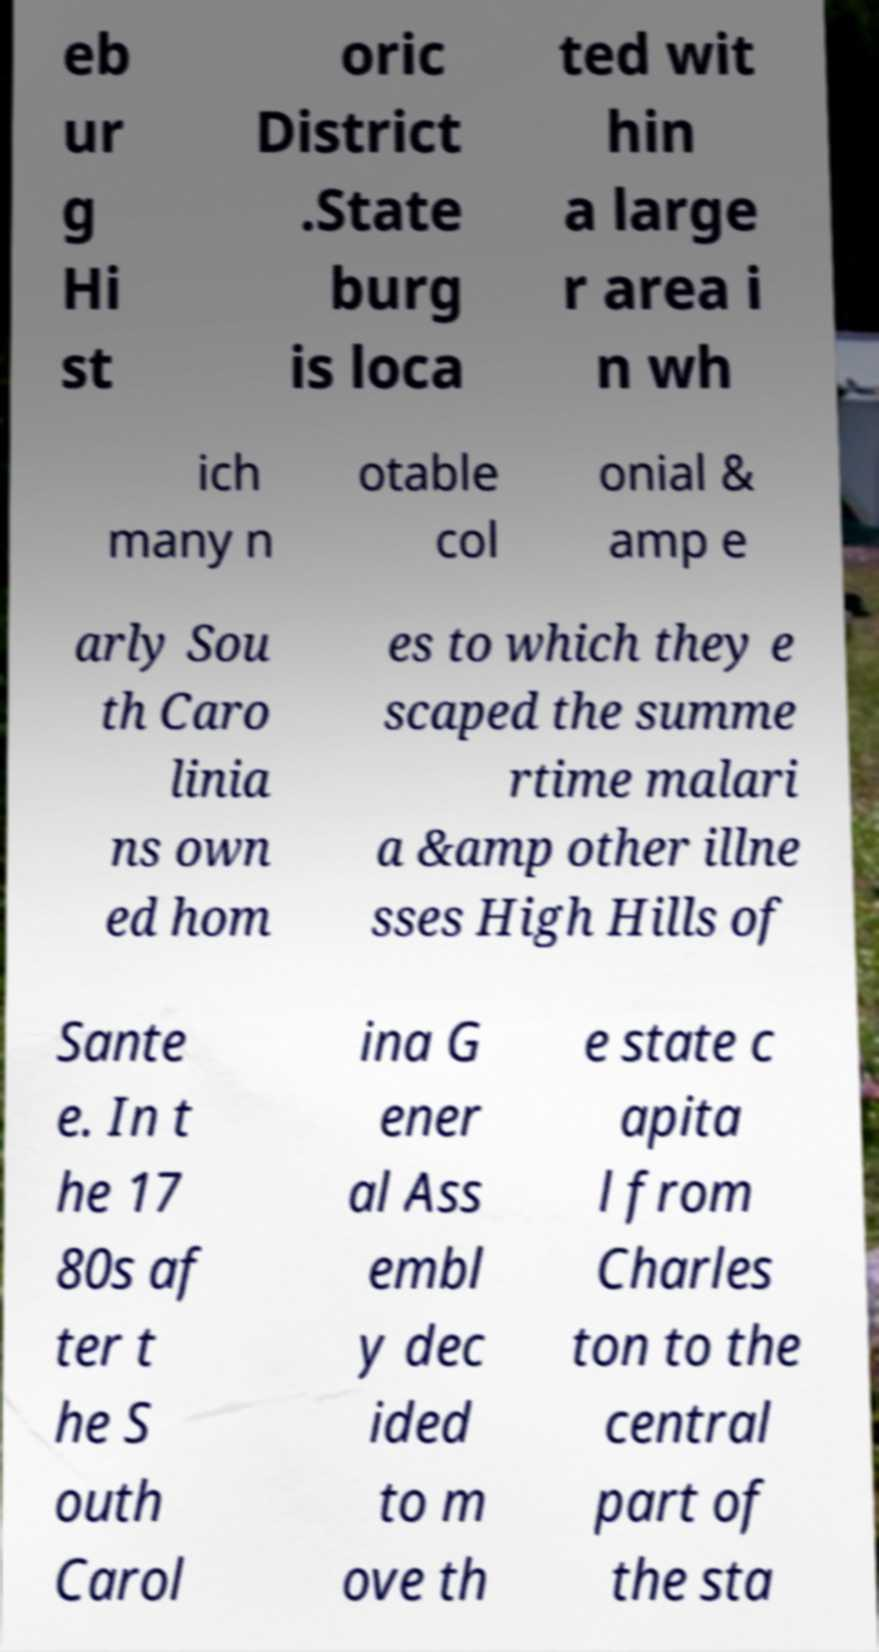There's text embedded in this image that I need extracted. Can you transcribe it verbatim? eb ur g Hi st oric District .State burg is loca ted wit hin a large r area i n wh ich many n otable col onial & amp e arly Sou th Caro linia ns own ed hom es to which they e scaped the summe rtime malari a &amp other illne sses High Hills of Sante e. In t he 17 80s af ter t he S outh Carol ina G ener al Ass embl y dec ided to m ove th e state c apita l from Charles ton to the central part of the sta 